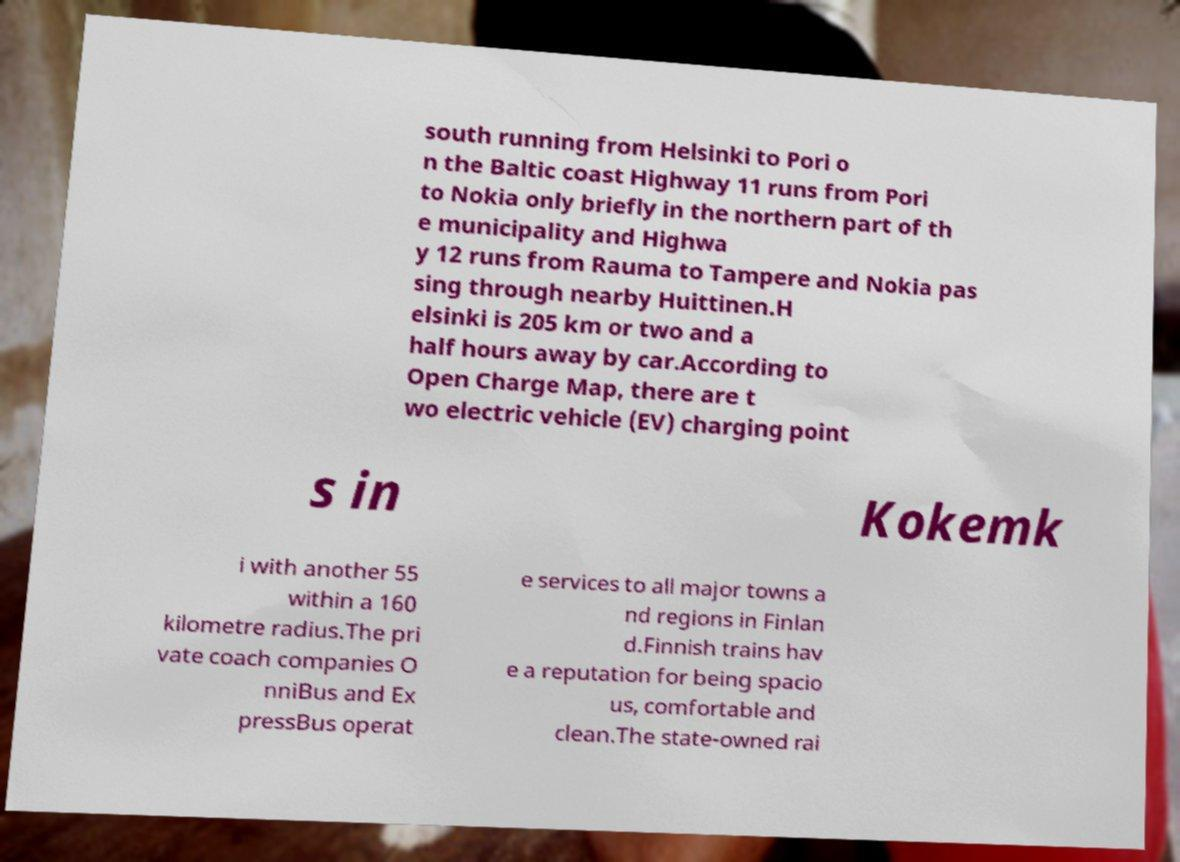What messages or text are displayed in this image? I need them in a readable, typed format. south running from Helsinki to Pori o n the Baltic coast Highway 11 runs from Pori to Nokia only briefly in the northern part of th e municipality and Highwa y 12 runs from Rauma to Tampere and Nokia pas sing through nearby Huittinen.H elsinki is 205 km or two and a half hours away by car.According to Open Charge Map, there are t wo electric vehicle (EV) charging point s in Kokemk i with another 55 within a 160 kilometre radius.The pri vate coach companies O nniBus and Ex pressBus operat e services to all major towns a nd regions in Finlan d.Finnish trains hav e a reputation for being spacio us, comfortable and clean.The state-owned rai 